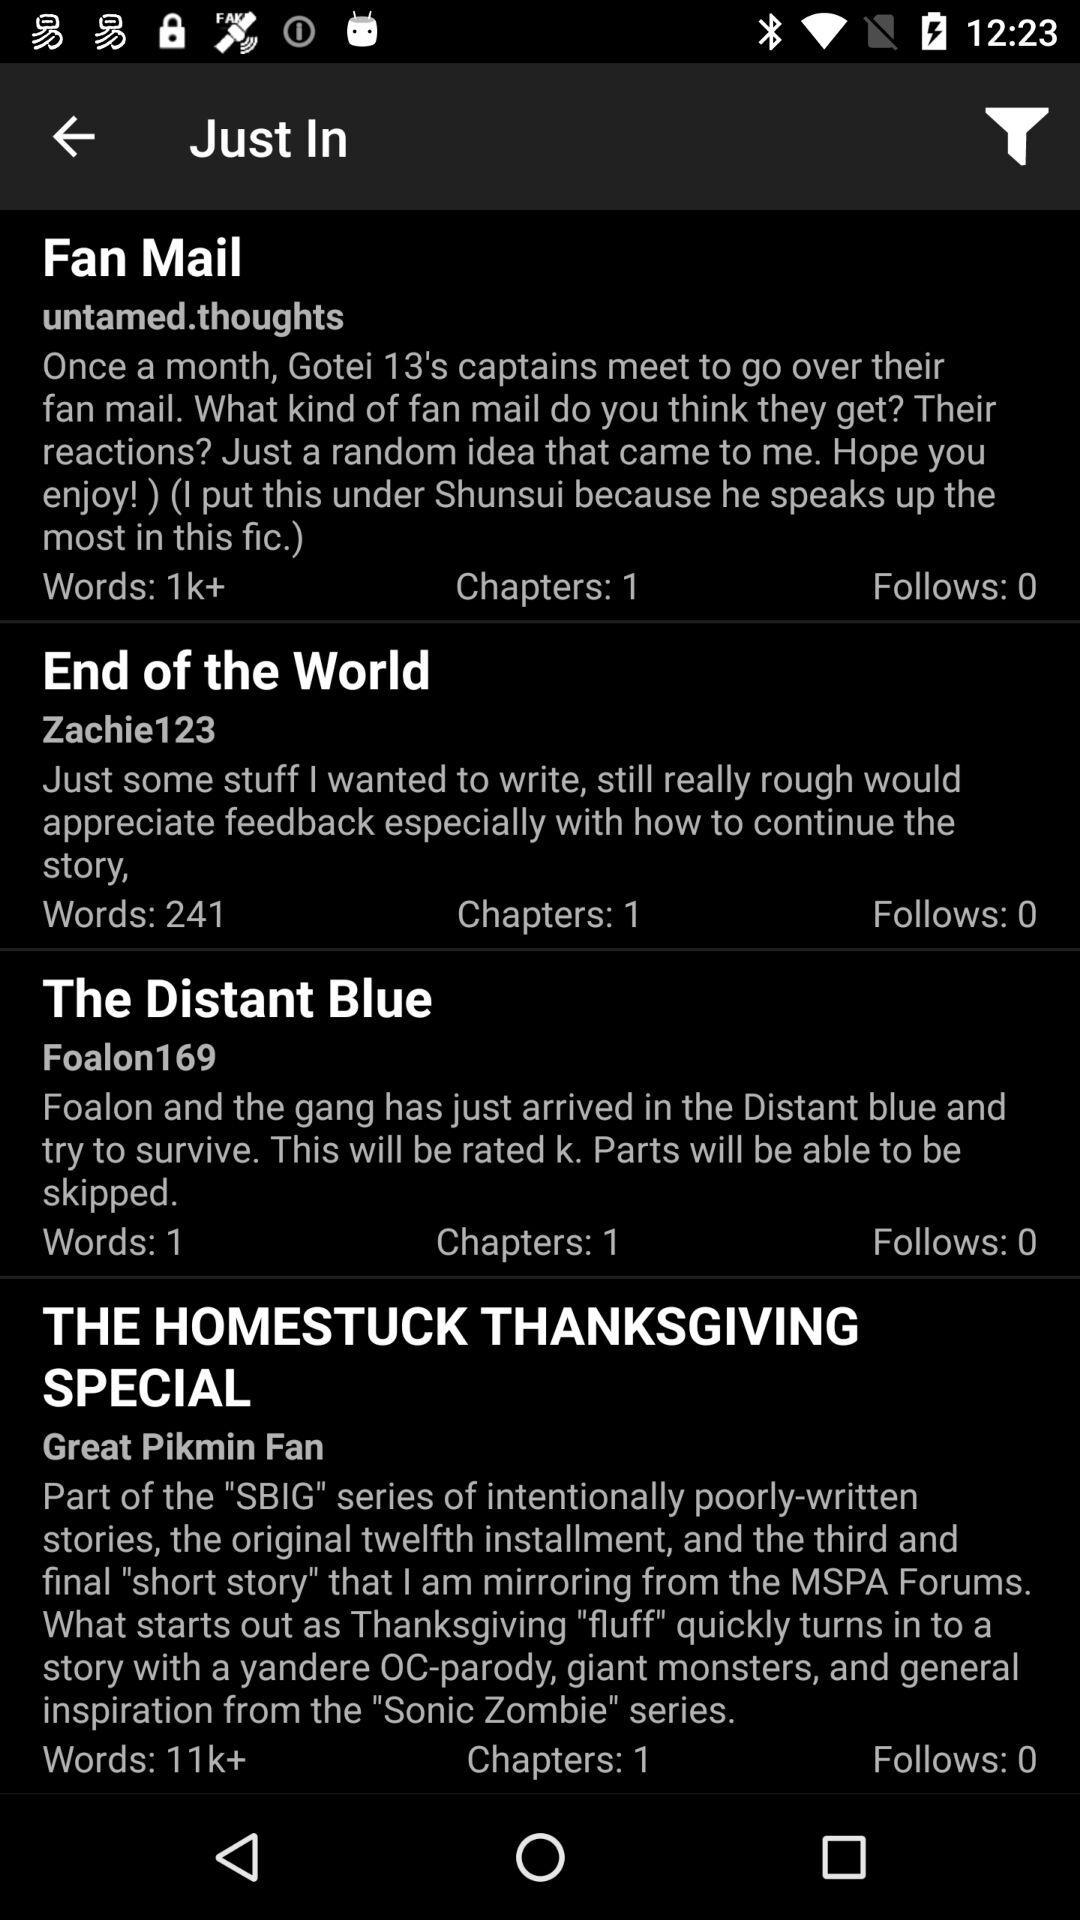How many members follow the "Fan Mail"? The "Fan Mail" is followed by 0 members. 